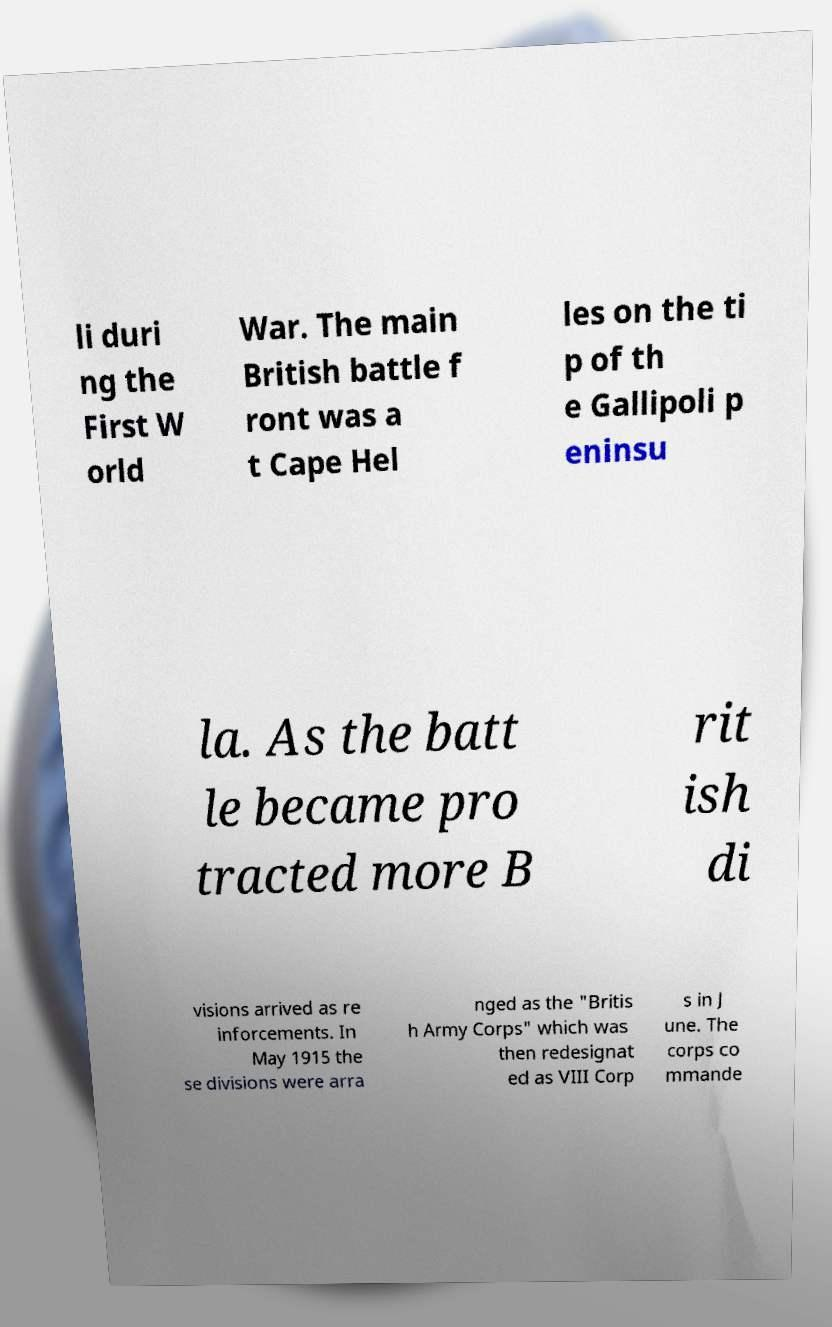I need the written content from this picture converted into text. Can you do that? li duri ng the First W orld War. The main British battle f ront was a t Cape Hel les on the ti p of th e Gallipoli p eninsu la. As the batt le became pro tracted more B rit ish di visions arrived as re inforcements. In May 1915 the se divisions were arra nged as the "Britis h Army Corps" which was then redesignat ed as VIII Corp s in J une. The corps co mmande 